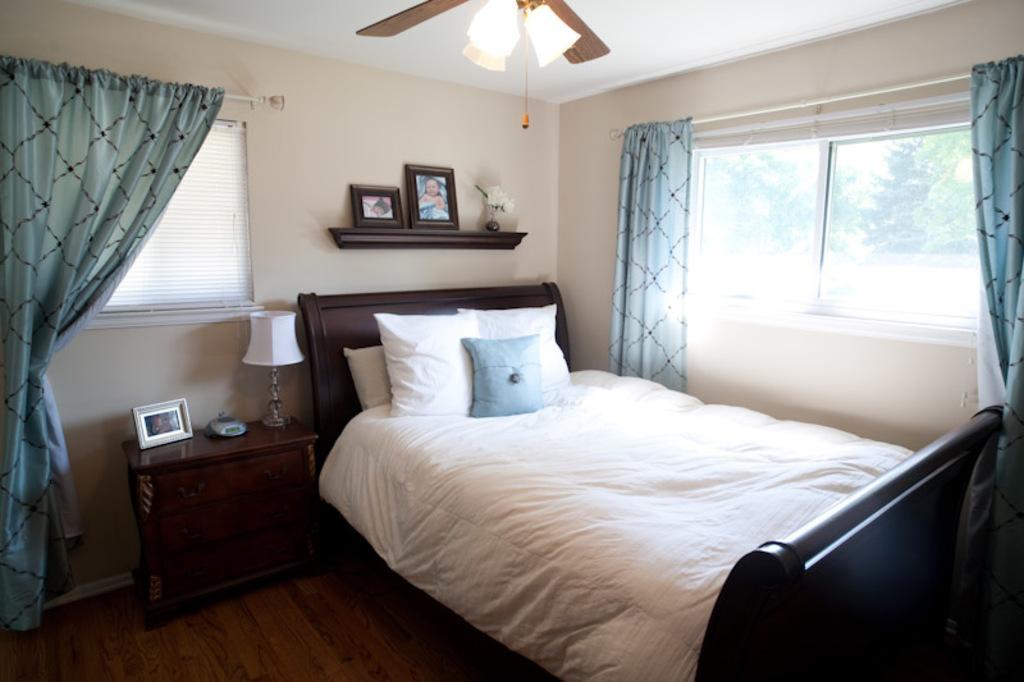Please provide a concise description of this image. This is the picture of a room. In this image there are pillows on the bed. There are curtains at the windows. There is a lamp, frame and device on the table. There are frames and there is a flower vase on the wall. At the top there is a light and fan. There are trees behind the window. 